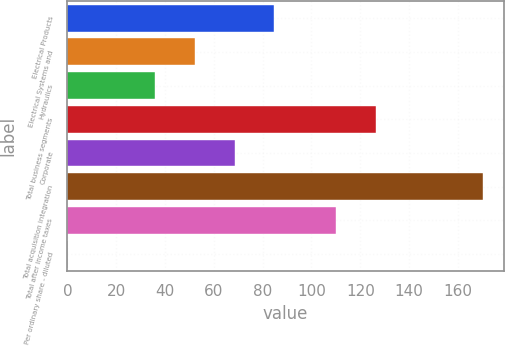<chart> <loc_0><loc_0><loc_500><loc_500><bar_chart><fcel>Electrical Products<fcel>Electrical Systems and<fcel>Hydraulics<fcel>Total business segments<fcel>Corporate<fcel>Total acquisition integration<fcel>Total after income taxes<fcel>Per ordinary share - diluted<nl><fcel>84.84<fcel>52.28<fcel>36<fcel>126.28<fcel>68.56<fcel>170.28<fcel>110<fcel>0.23<nl></chart> 